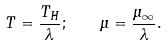Convert formula to latex. <formula><loc_0><loc_0><loc_500><loc_500>T = { \frac { T _ { H } } { \lambda } } ; \quad \mu = { \frac { \mu _ { \infty } } { \lambda } } .</formula> 